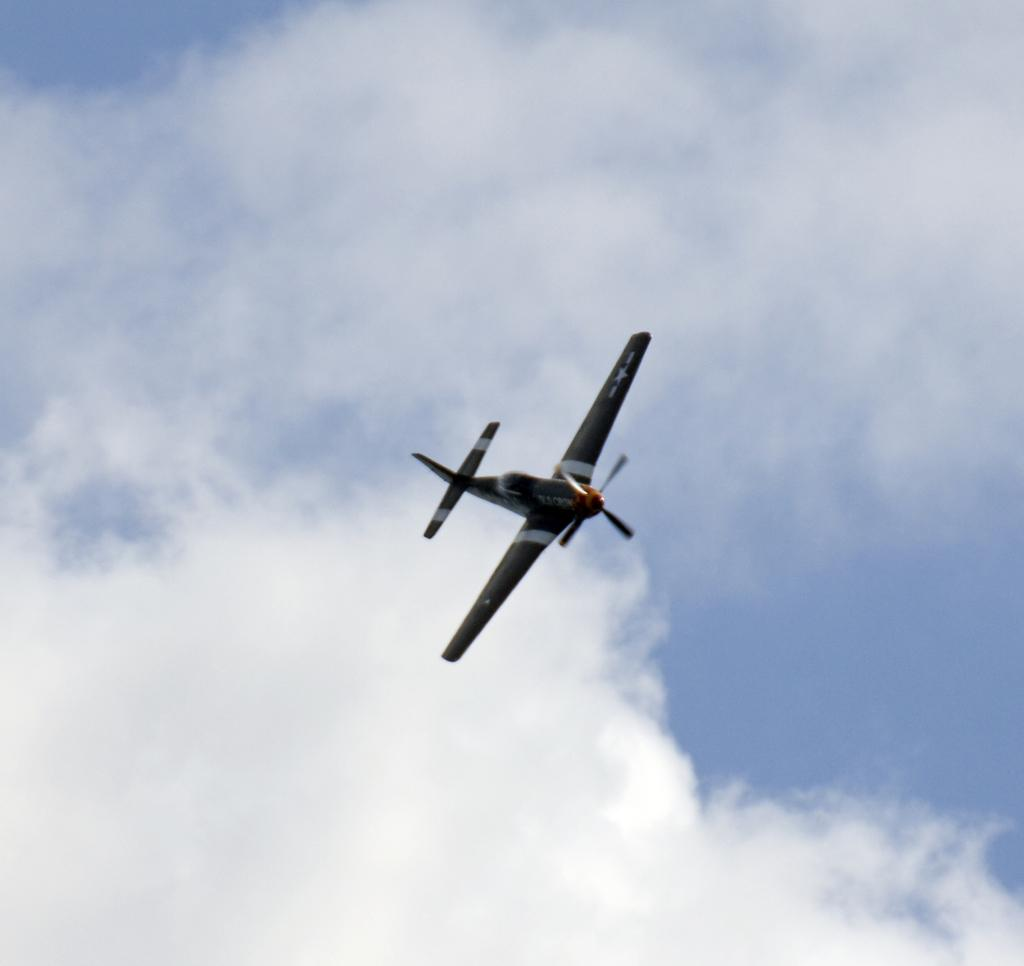What is the main subject of the image? The main subject of the image is a helicopter. What is the helicopter doing in the image? The helicopter is flying in the air. What can be seen in the background of the image? The sky is visible in the image. What is the weather like in the image? The sky appears to be cloudy in the image. Can you see an owl waving at the helicopter in the image? There is no owl or waving gesture present in the image. 